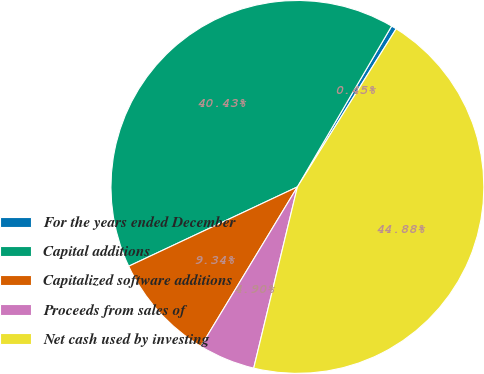Convert chart. <chart><loc_0><loc_0><loc_500><loc_500><pie_chart><fcel>For the years ended December<fcel>Capital additions<fcel>Capitalized software additions<fcel>Proceeds from sales of<fcel>Net cash used by investing<nl><fcel>0.45%<fcel>40.43%<fcel>9.34%<fcel>4.9%<fcel>44.88%<nl></chart> 